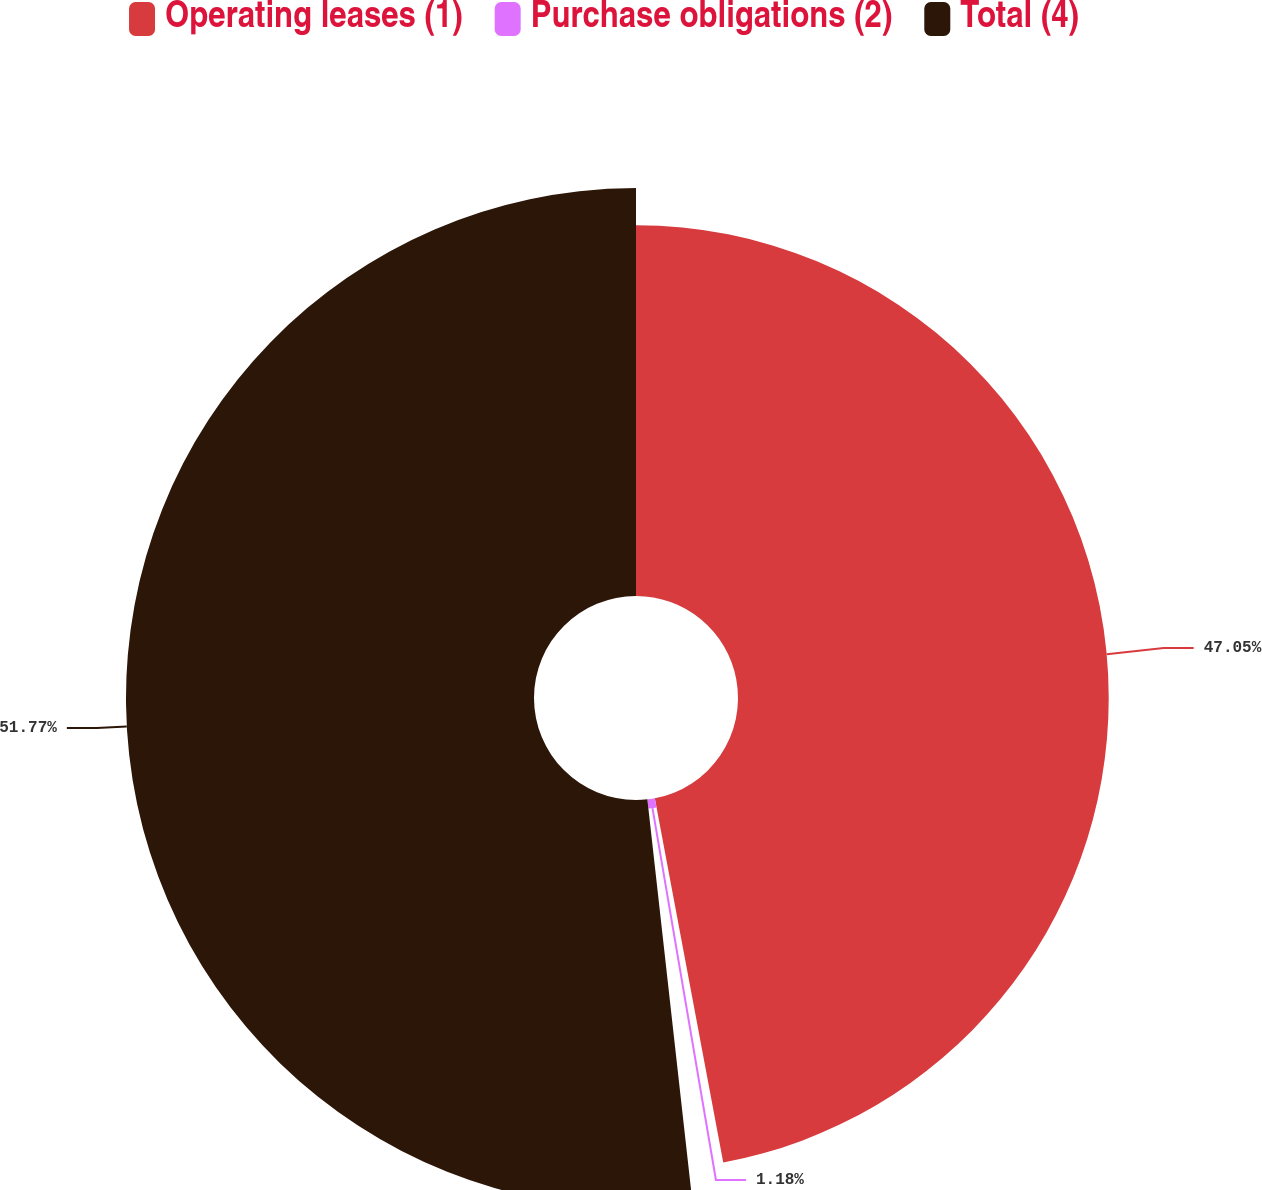Convert chart. <chart><loc_0><loc_0><loc_500><loc_500><pie_chart><fcel>Operating leases (1)<fcel>Purchase obligations (2)<fcel>Total (4)<nl><fcel>47.05%<fcel>1.18%<fcel>51.78%<nl></chart> 